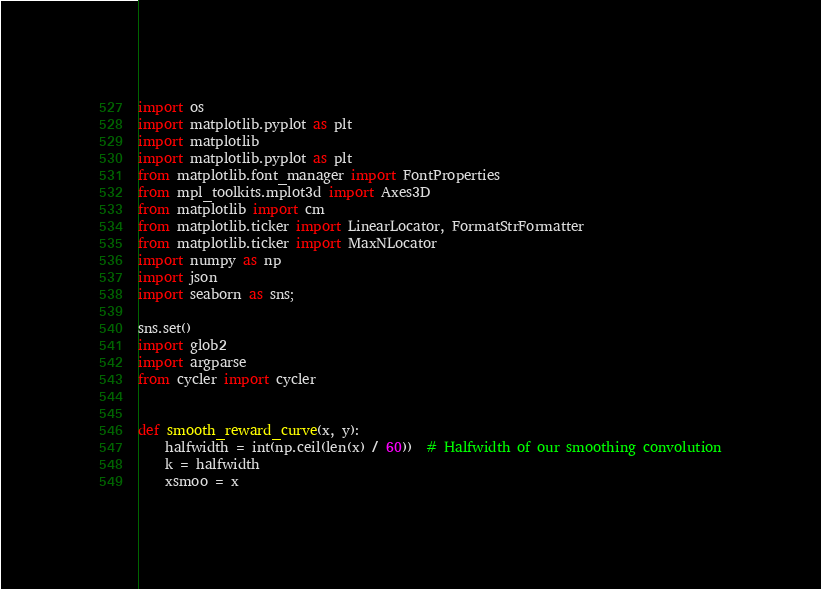<code> <loc_0><loc_0><loc_500><loc_500><_Python_>import os
import matplotlib.pyplot as plt
import matplotlib
import matplotlib.pyplot as plt
from matplotlib.font_manager import FontProperties
from mpl_toolkits.mplot3d import Axes3D
from matplotlib import cm
from matplotlib.ticker import LinearLocator, FormatStrFormatter
from matplotlib.ticker import MaxNLocator
import numpy as np
import json
import seaborn as sns;

sns.set()
import glob2
import argparse
from cycler import cycler


def smooth_reward_curve(x, y):
    halfwidth = int(np.ceil(len(x) / 60))  # Halfwidth of our smoothing convolution
    k = halfwidth
    xsmoo = x</code> 